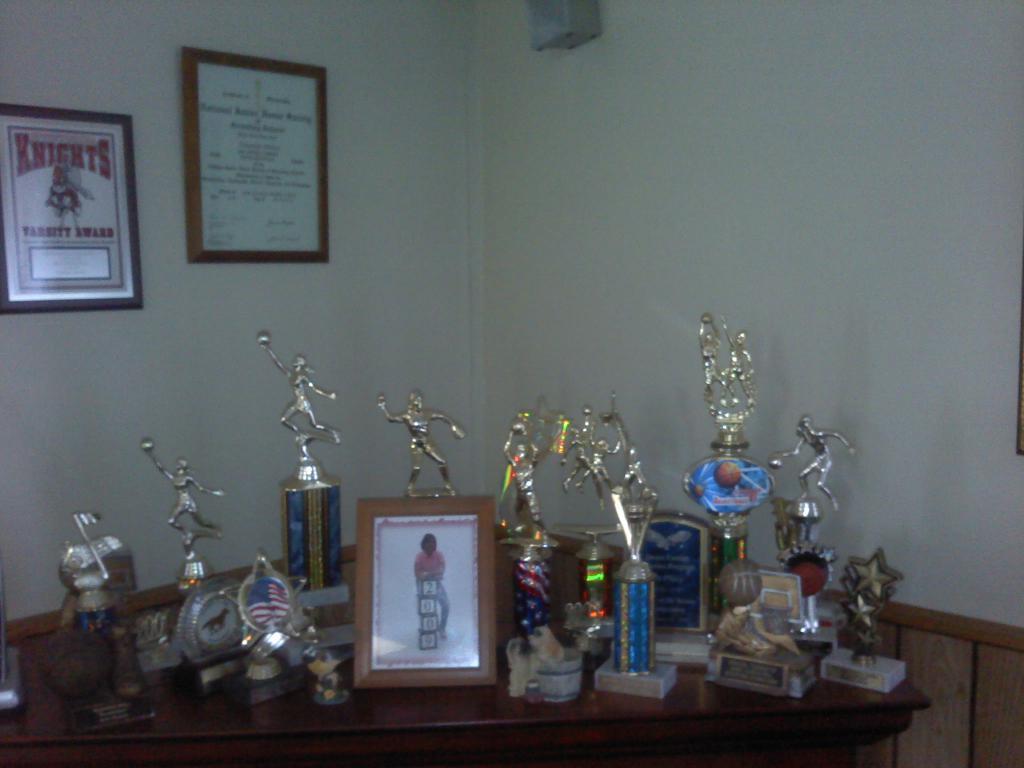How would you summarize this image in a sentence or two? This picture shows mementos on the table and a frame to the wall 